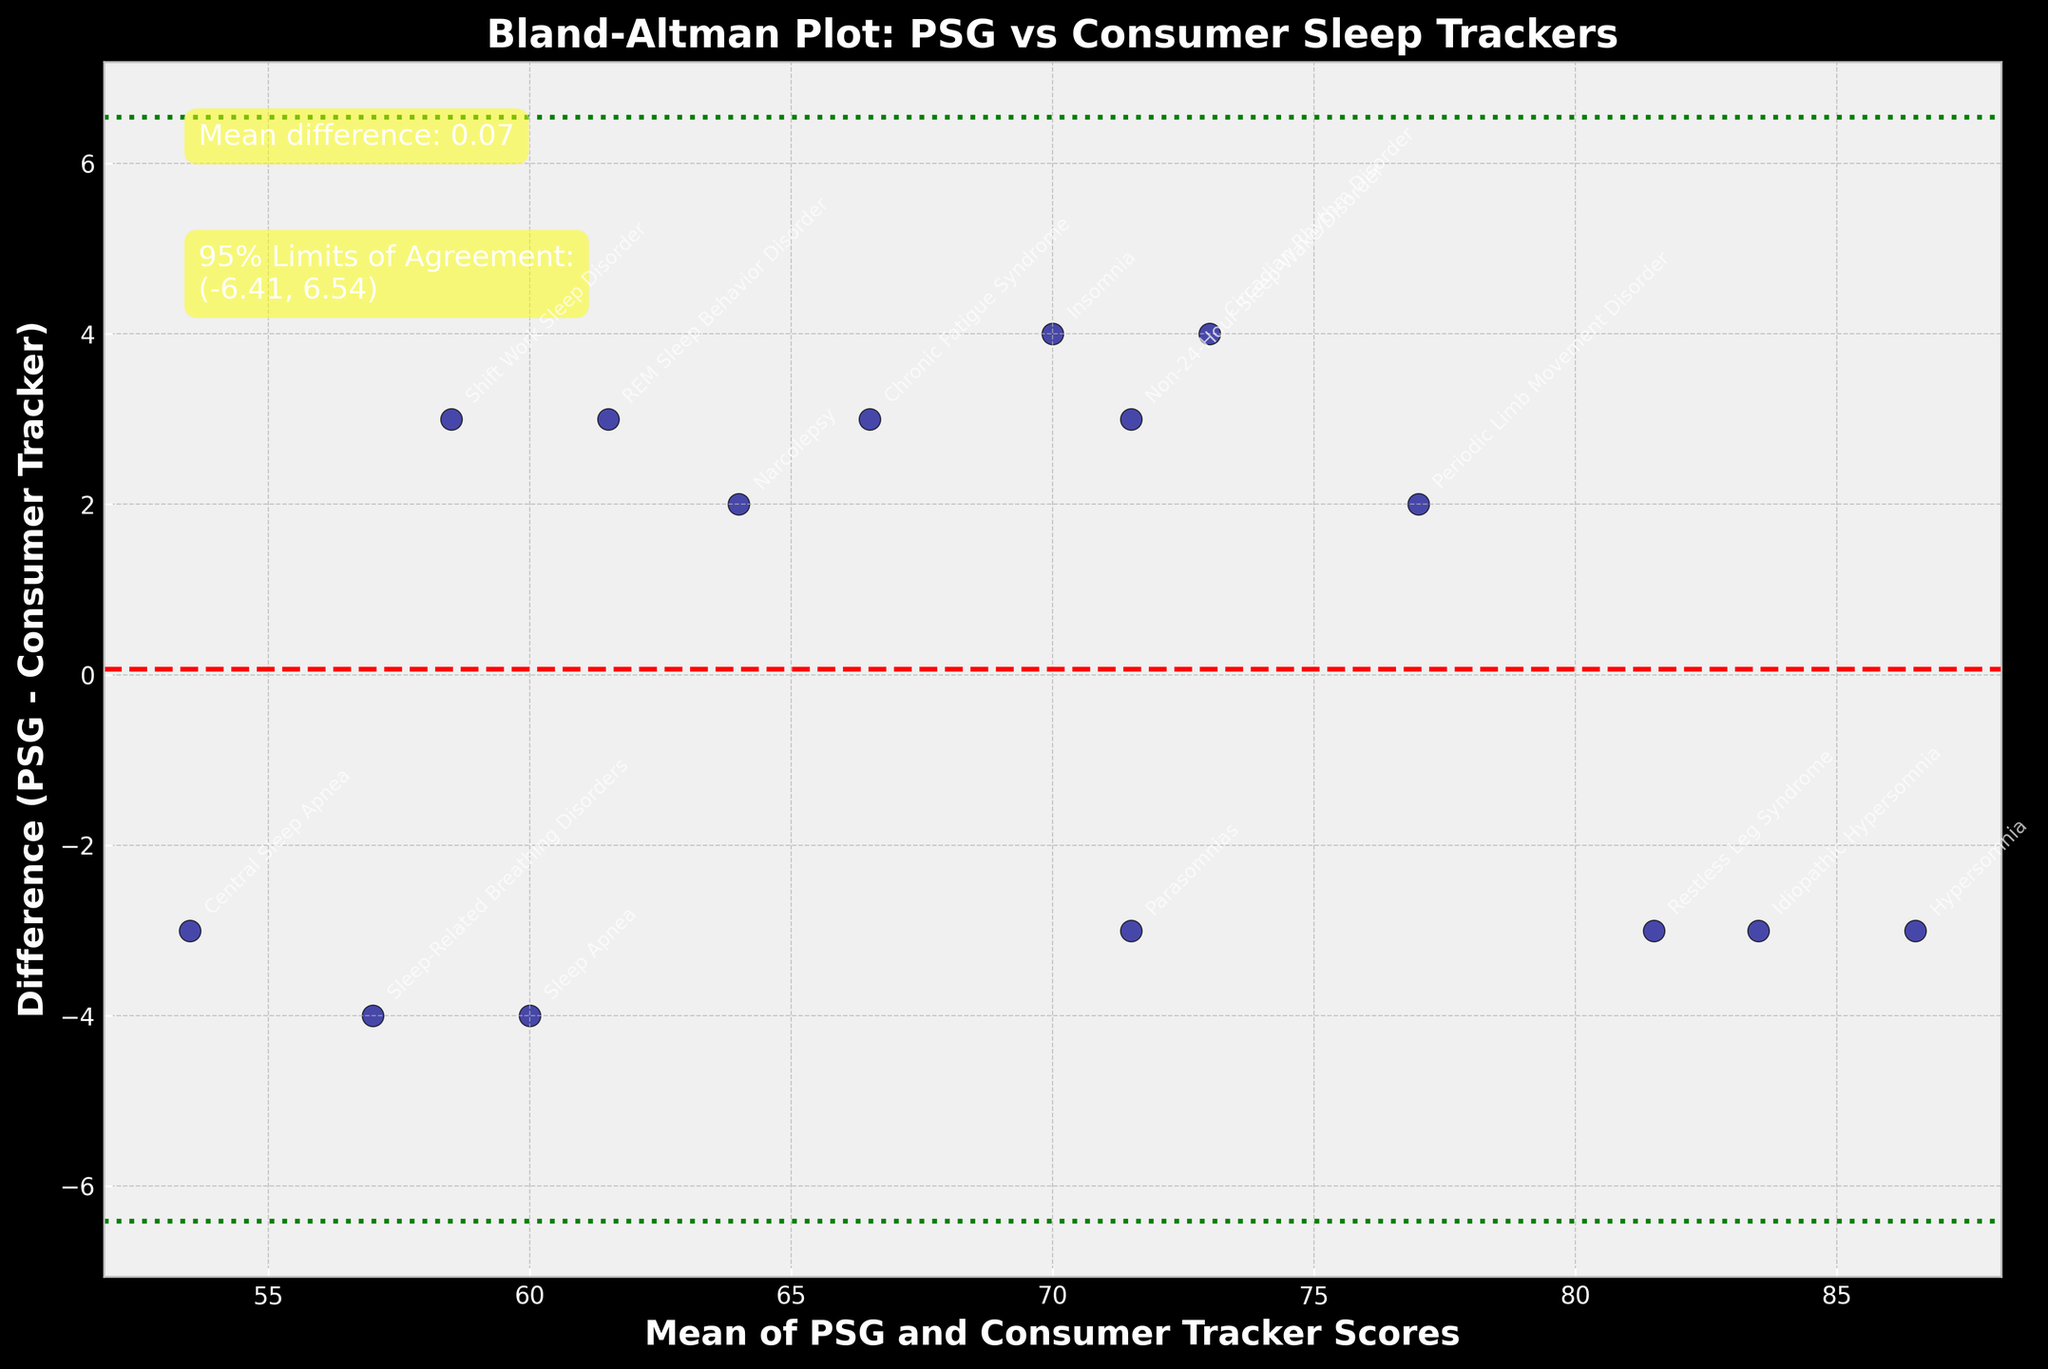What is the title of the plot? The title is the text that appears at the top of the plot, typically describing the main topic or purpose of the figure. In this case, it reads "Bland-Altman Plot: PSG vs Consumer Sleep Trackers."
Answer: Bland-Altman Plot: PSG vs Consumer Sleep Trackers What do the x-axis and y-axis represent? The axes are labeled to indicate what the respective data points correspond to. The x-axis shows the "Mean of PSG and Consumer Tracker Scores," and the y-axis shows the "Difference (PSG - Consumer Tracker)."
Answer: x-axis: Mean of PSG and Consumer Tracker Scores; y-axis: Difference (PSG - Consumer Tracker) What is the mean difference between the PSG and consumer tracker scores? The mean difference is indicated by a red dashed line and is numerically annotated on the plot. It states "Mean difference: -0.13."
Answer: -0.13 What are the limits of agreement for the differences in scores? The limits of agreement are depicted by green dotted lines and are numerically annotated on the plot as well. It reads "95% Limits of Agreement: (-8.96, 8.69)."
Answer: (-8.96, 8.69) How many sleep disorder types are labeled in the plot? Each data point represents a sleep disorder type and is annotated with text. Counting the annotations, we see there are 15 different sleep disorder types.
Answer: 15 Which sleep disorder has the largest positive difference between PSG and consumer tracker scores? By looking at the y-values of the plotted points, the highest positive difference is around 4-5 units. This is annotated as "Sleep Apnea."
Answer: Sleep Apnea Which sleep disorder lies closest to the mean difference line? The data point closest to the red dashed mean difference line indicates the smallest absolute difference. This is annotated as "Non-24-Hour Sleep-Wake Disorder."
Answer: Non-24-Hour Sleep-Wake Disorder What is the PSG score for Idiopathic Hypersomnia, and what is the difference between this score and the consumer tracker score? The point annotated with "Idiopathic Hypersomnia" is used. Checking the y-axis value, the difference is 82-85 = -3. The PSG score for Idiopathic Hypersomnia is 82.
Answer: PSG: 82, Difference: -3 Identify two sleep disorders with negative differences between their PSG and consumer tracker scores. Negative differences are below the mean difference line. By examining the plot annotations below this line, "Restless Leg Syndrome" and "Non-24-Hour Sleep-Wake Disorder" have negative differences.
Answer: Restless Leg Syndrome, Non-24-Hour Sleep-Wake Disorder 